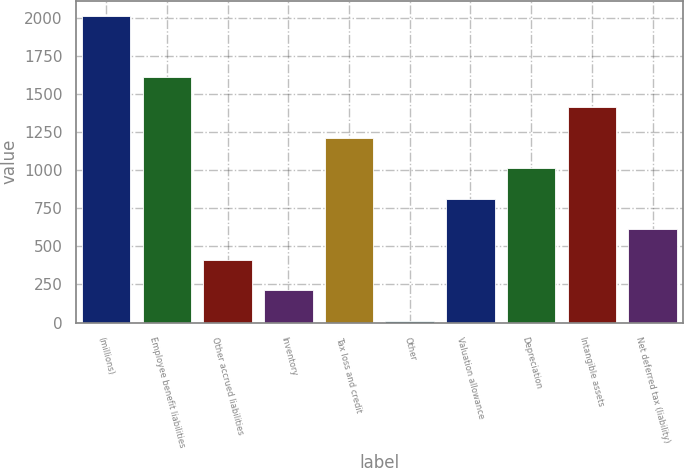Convert chart to OTSL. <chart><loc_0><loc_0><loc_500><loc_500><bar_chart><fcel>(millions)<fcel>Employee benefit liabilities<fcel>Other accrued liabilities<fcel>Inventory<fcel>Tax loss and credit<fcel>Other<fcel>Valuation allowance<fcel>Depreciation<fcel>Intangible assets<fcel>Net deferred tax (liability)<nl><fcel>2012<fcel>1611.96<fcel>411.84<fcel>211.82<fcel>1211.92<fcel>11.8<fcel>811.88<fcel>1011.9<fcel>1411.94<fcel>611.86<nl></chart> 